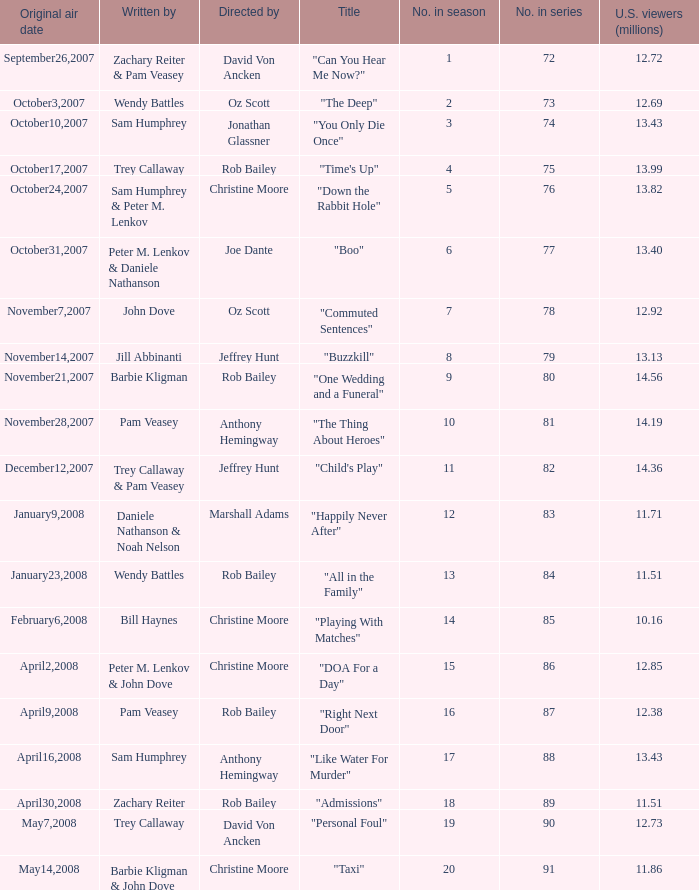How many millions of U.S. viewers watched the episode directed by Rob Bailey and written by Pam Veasey? 12.38. 